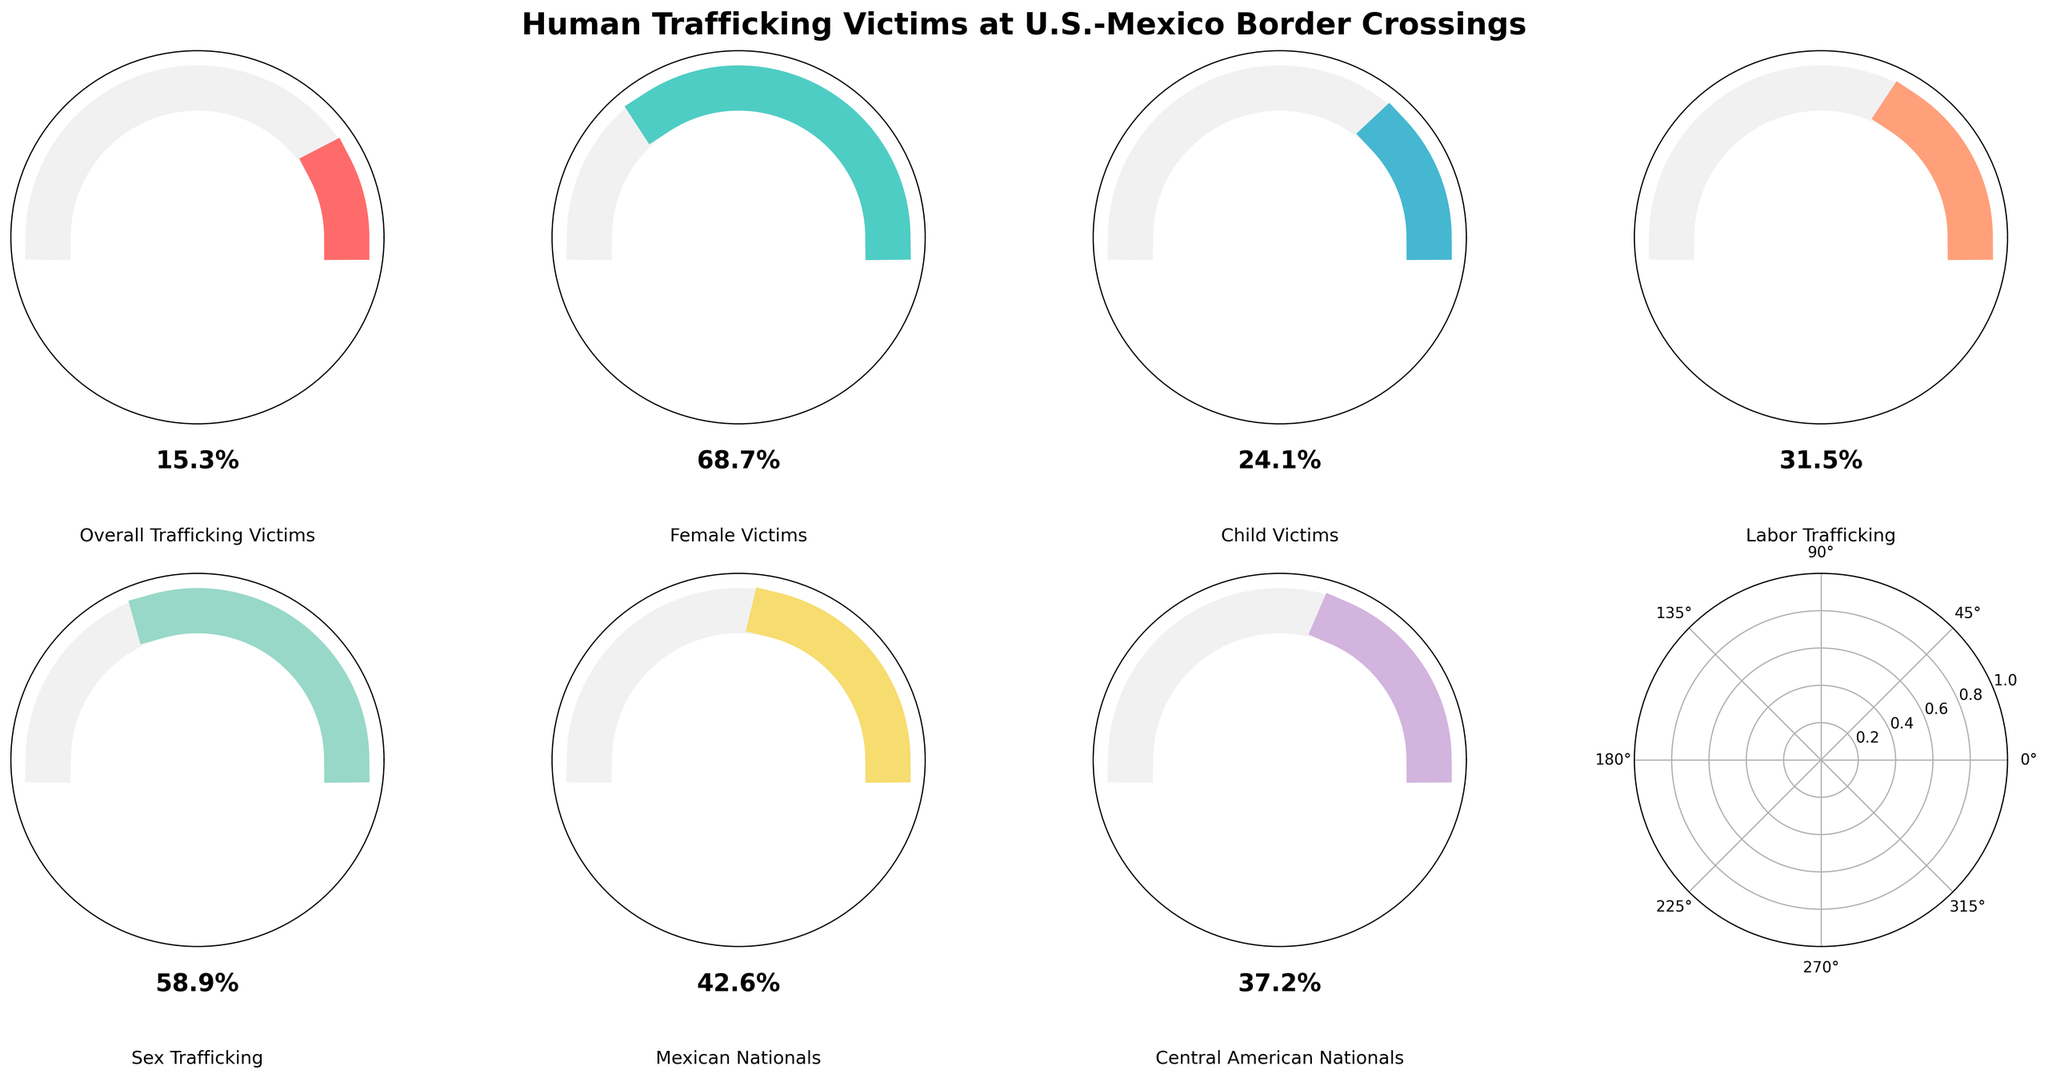What's the title of the figure? The title is positioned at the top of the figure and it reads: "Human Trafficking Victims at U.S.-Mexico Border Crossings".
Answer: Human Trafficking Victims at U.S.-Mexico Border Crossings Which category has the highest percentage? By observing the plot, the category "Female Victims" has the gauge most filled, indicating the highest percentage.
Answer: Female Victims How many different categories are presented in the figure? There are 7 different gauges, each representing a different category.
Answer: 7 What is the percentage of Child Victims identified? The gauge labeled "Child Victims" shows a percentage value.
Answer: 24.1% Which category has a higher percentage, Labor Trafficking or Sex Trafficking? Comparing the gauges, the "Sex Trafficking" category is more filled than the "Labor Trafficking" category.
Answer: Sex Trafficking What is the average percentage of Female Victims and Child Victims combined? Add the percentages of Female Victims (68.7%) and Child Victims (24.1%) and divide by 2. The calculation is (68.7 + 24.1) / 2.
Answer: 46.4% Which category has the least representation in the figure? By observing the gauges, the category with the least filled gauge is "Overall Trafficking Victims".
Answer: Overall Trafficking Victims How much higher is the percentage of Mexican Nationals compared to Central American Nationals involved in trafficking? Subtract the percentage of Central American Nationals (37.2%) from the percentage of Mexican Nationals (42.6%). The calculation is 42.6 - 37.2.
Answer: 5.4% If the total number of sex trafficking victims identified is 10000, how many female victims might there be given their percentage? Use the percentage for Female Victims, 68.7%. Multiply 10000 by 68.7/100 to get the number of female victims. The calculation is 10000 * 0.687.
Answer: 6870 